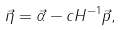<formula> <loc_0><loc_0><loc_500><loc_500>\vec { \eta } = \vec { \alpha } - c H ^ { - 1 } \vec { p } ,</formula> 